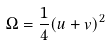Convert formula to latex. <formula><loc_0><loc_0><loc_500><loc_500>\Omega = \frac { 1 } { 4 } ( u + v ) ^ { 2 }</formula> 